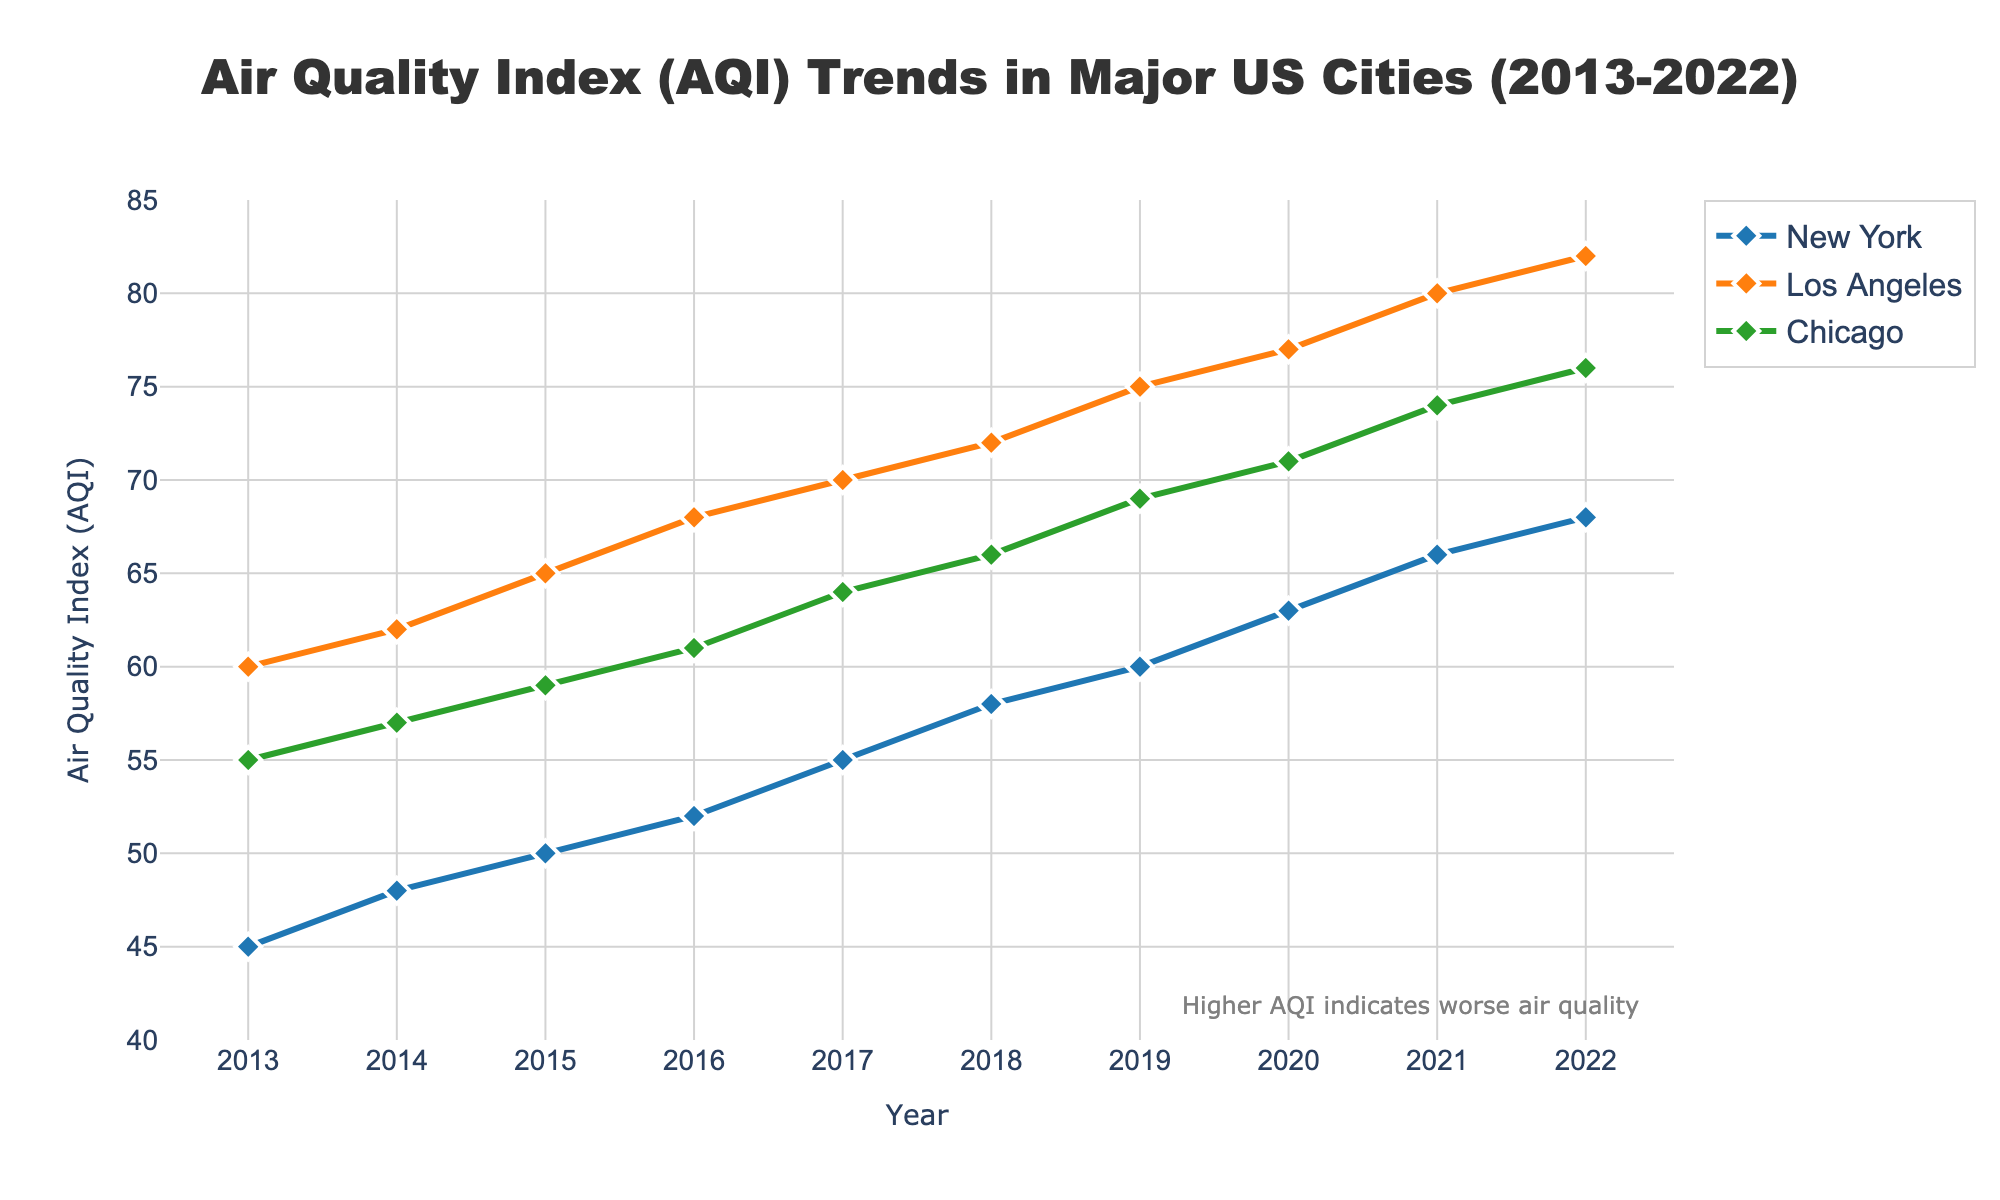What is the overall title of the plot? The figure's title is at the top of the plot. It reads: "Air Quality Index (AQI) Trends in Major US Cities (2013-2022)."
Answer: Air Quality Index (AQI) Trends in Major US Cities (2013-2022) What is the AQI for New York in 2017? Locate the point on the New York line that corresponds to 2017 on the x-axis, then read the AQI on the y-axis.
Answer: 55 Which city has the highest AQI in 2022, and what is it? Look for the data point in 2022 on the x-axis and identify which city's line has the highest y-value.
Answer: Los Angeles, 82 How did the AQI of Los Angeles change from 2013 to 2022? Identify the AQI for Los Angeles in 2013 (60) and in 2022 (82) by tracing the city's line, then calculate the difference.
Answer: Increased by 22 What is the difference in AQI between Chicago and New York in 2020? Locate the 2020 data points for Chicago (71) and New York (63), then subtract the AQI of New York from that of Chicago.
Answer: 8 Which city showed the most significant AQI increase between 2013 and 2022? Calculate the difference between the AQI in 2013 and 2022 for each city and compare the increases. Los Angeles: 82 - 60 = 22, New York: 68 - 45 = 23, Chicago: 76 - 55 = 21.
Answer: New York, increase of 23 What is the trend in AQI for Chicago over the decade? Observe the Chicago line from 2013 to 2022. Describe whether it is generally increasing, decreasing, or stable.
Answer: Increasing Is there any year where all three cities have an AQI value above 60? Check each year from 2013 to 2022 and see if all three AQI values are above 60. Only check 2020, 2021, and 2022 for a possible match.
Answer: 2021, 2022 What year did New York surpass an AQI of 50 for the first time? Trace the New York line and find the first year where the AQI surpasses 50.
Answer: 2016 What is the average AQI for New York from 2013 to 2022? Sum New York's AQI values from 2013 to 2022 and divide by the number of years (10). (45+48+50+52+55+58+60+63+66+68) = 525 / 10
Answer: 52.5 